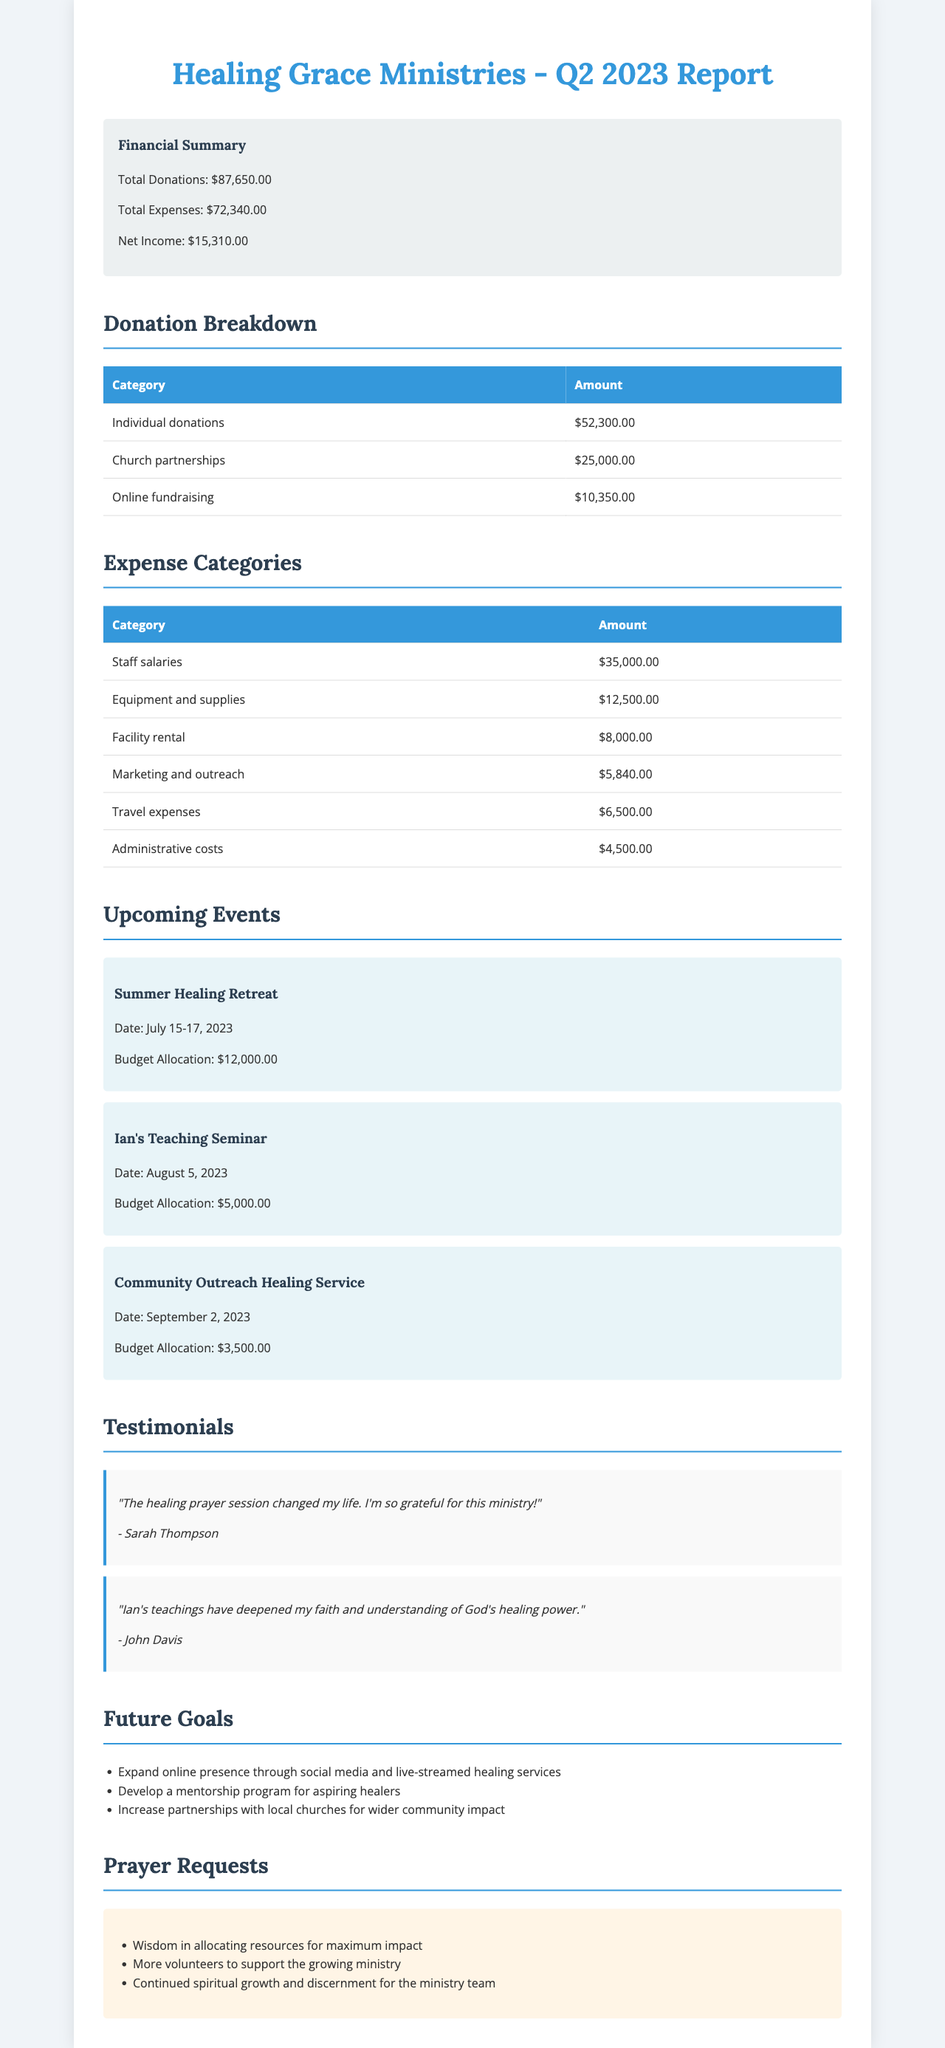What is the total donations amount? The total donations amount is stated clearly in the financial summary section of the document.
Answer: $87,650.00 What is the budget allocation for the Summer Healing Retreat? The budget allocation for this specific event is listed under the upcoming events section.
Answer: $12,000.00 What is the net income for the quarter? The net income is calculated as total donations minus total expenses, which is shown in the financial summary.
Answer: $15,310.00 How much was spent on staff salaries? This figure is detailed in the expense categories section of the document.
Answer: $35,000.00 What is one of the future goals mentioned? The future goals section lists specific objectives for the ministry and one of them can be used.
Answer: Expand online presence through social media and live-streamed healing services What is the date for Ian's Teaching Seminar? The date is specified next to the event name in the upcoming events section.
Answer: August 5, 2023 Who provided a testimonial regarding Ian's teachings? The testimonials section includes names and their respective testimonies.
Answer: John Davis What was the total expenses for the quarter? The total expenses figure is found in the financial summary of the document.
Answer: $72,340.00 What is one of the prayer requests for the ministry? The prayer requests are listed in a dedicated section, and one can be selected.
Answer: More volunteers to support the growing ministry 